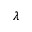Convert formula to latex. <formula><loc_0><loc_0><loc_500><loc_500>\lambda</formula> 